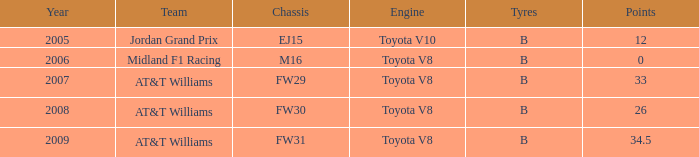What is the earliest year that had under 26 points and a toyota v8 engine? 2006.0. 